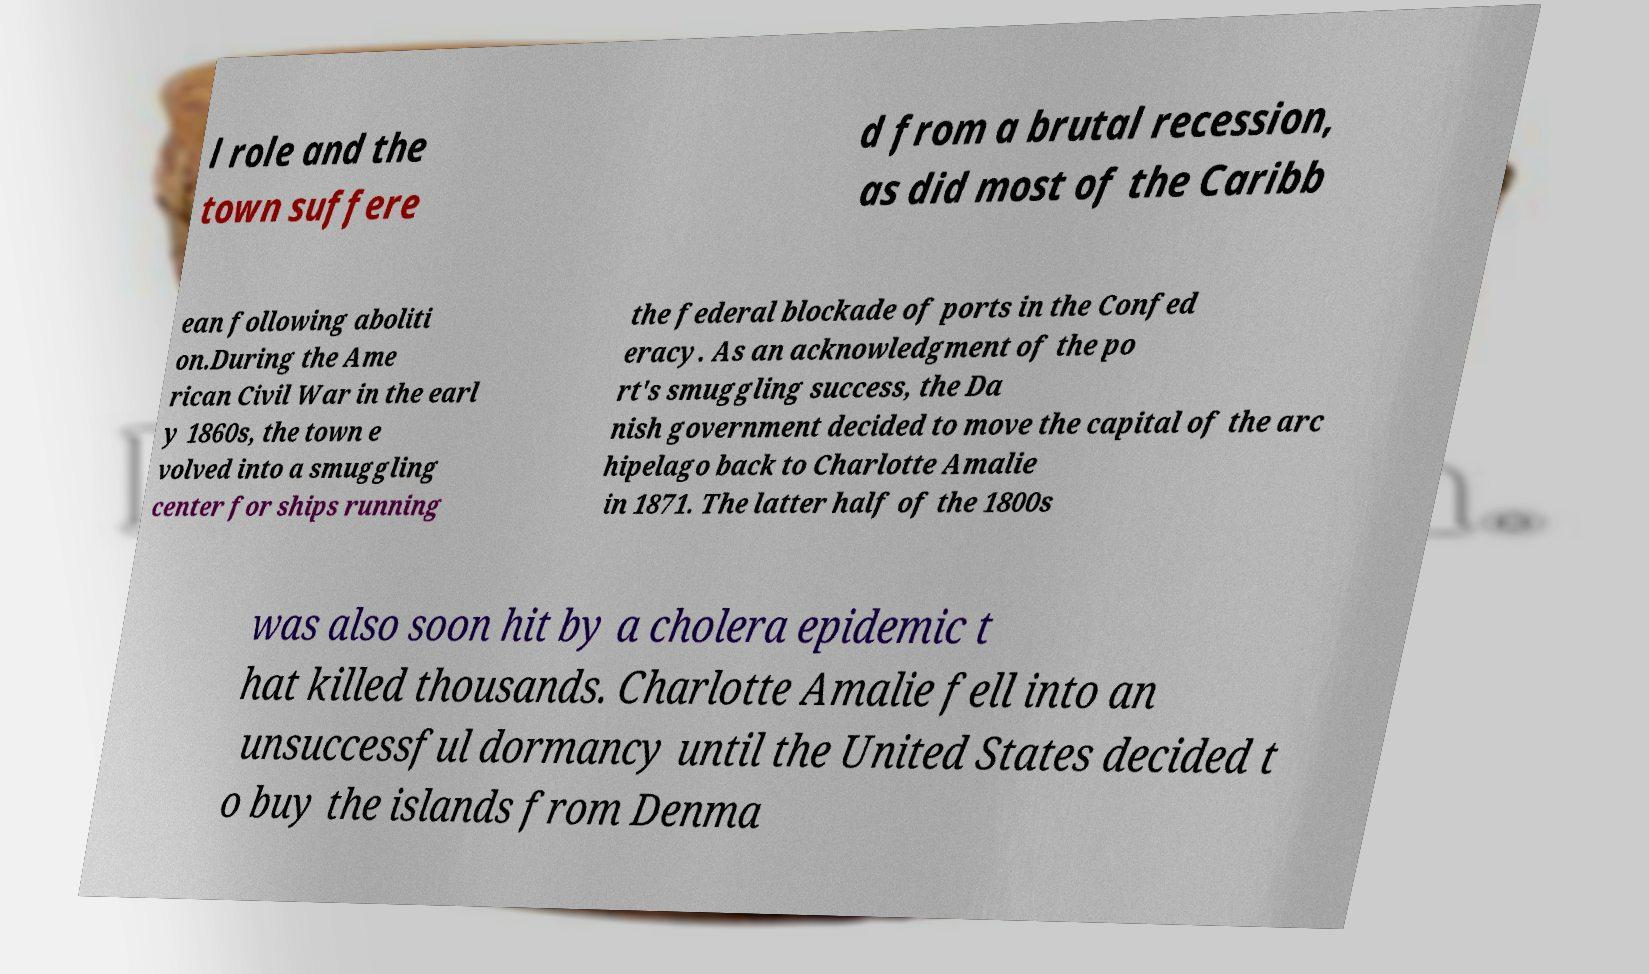Can you accurately transcribe the text from the provided image for me? l role and the town suffere d from a brutal recession, as did most of the Caribb ean following aboliti on.During the Ame rican Civil War in the earl y 1860s, the town e volved into a smuggling center for ships running the federal blockade of ports in the Confed eracy. As an acknowledgment of the po rt's smuggling success, the Da nish government decided to move the capital of the arc hipelago back to Charlotte Amalie in 1871. The latter half of the 1800s was also soon hit by a cholera epidemic t hat killed thousands. Charlotte Amalie fell into an unsuccessful dormancy until the United States decided t o buy the islands from Denma 